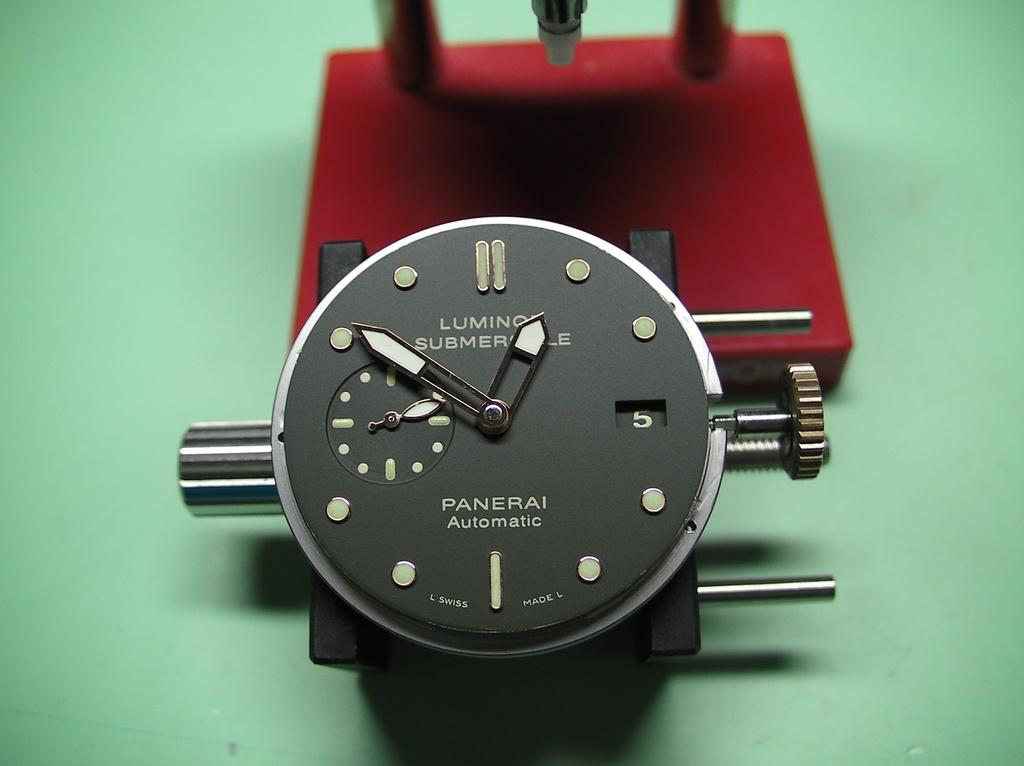<image>
Relay a brief, clear account of the picture shown. A panerai automatic tool of some sort laying on a green counter. 